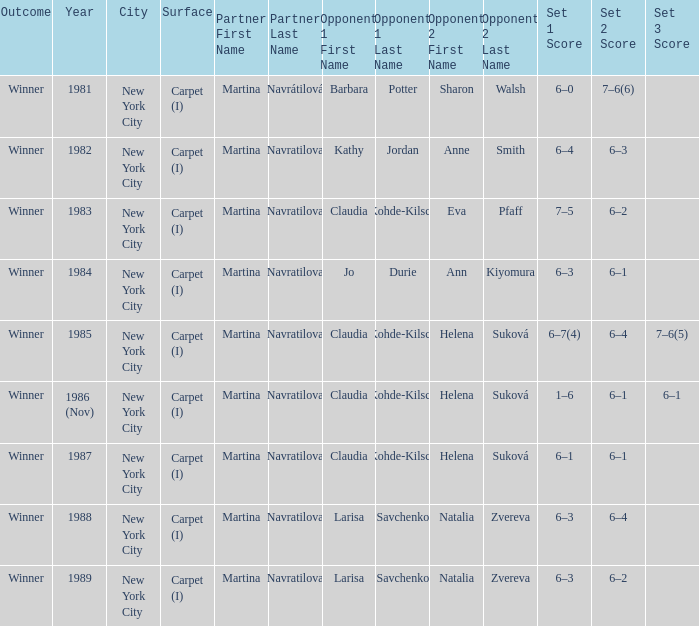Who were all of the opponents in 1984? Jo Durie Ann Kiyomura. 